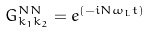<formula> <loc_0><loc_0><loc_500><loc_500>G _ { k _ { 1 } k _ { 2 } } ^ { N N } = e ^ { \left ( { - i N \omega _ { L } t } \right ) }</formula> 